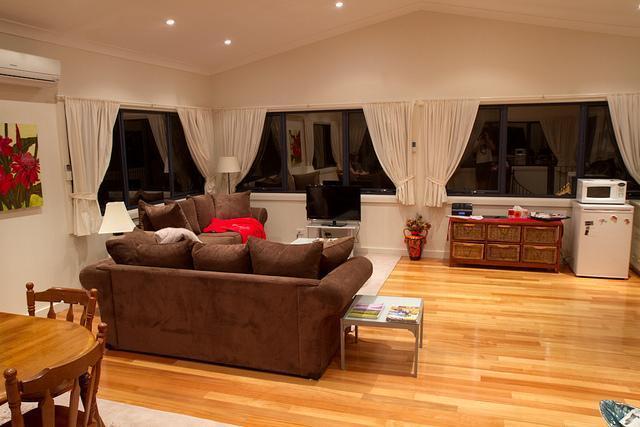How many chairs are there?
Give a very brief answer. 2. 